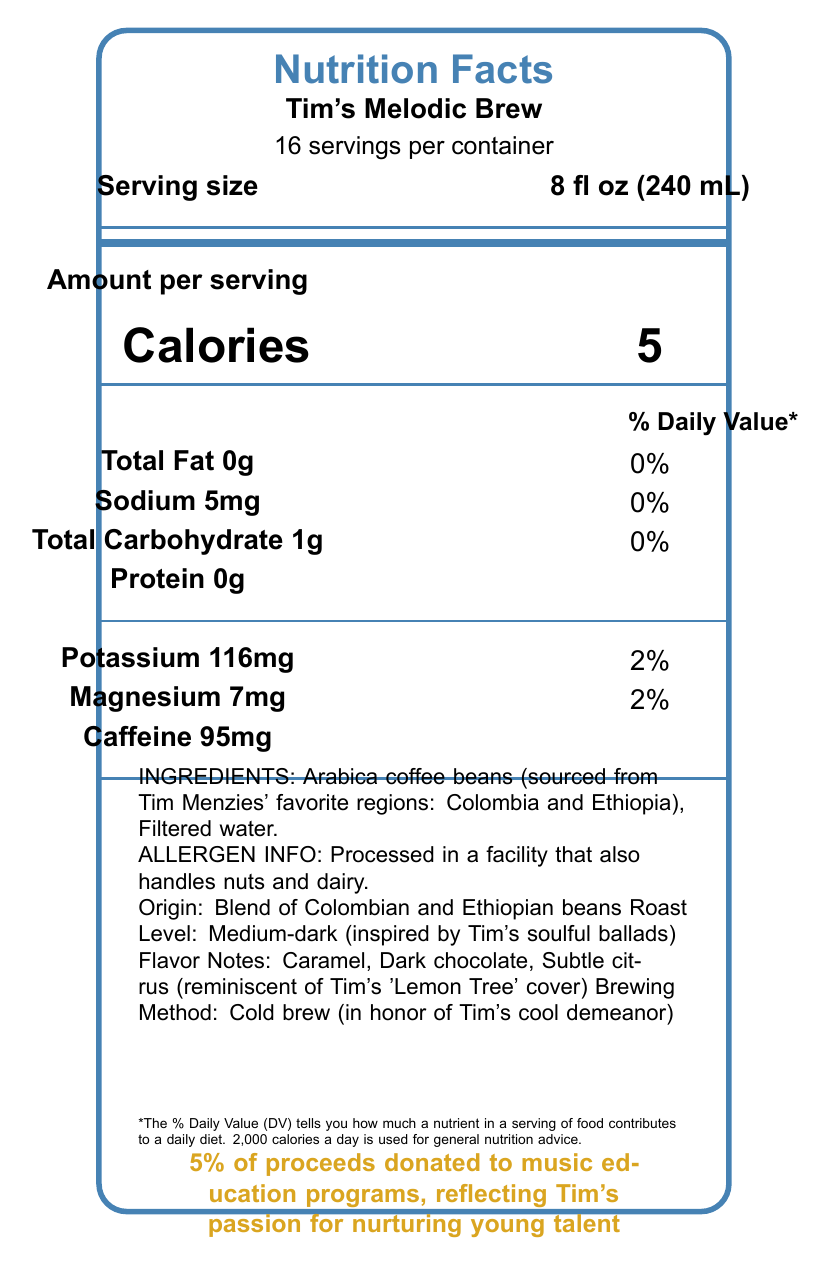What is the serving size of Tim's Melodic Brew? The serving size is clearly labeled as 8 fl oz (240 mL) in the document.
Answer: 8 fl oz (240 mL) How many servings are there per container of Tim's Melodic Brew? The label indicates that there are 16 servings per container.
Answer: 16 servings How many calories are there per serving of Tim's Melodic Brew? The document states that each serving contains 5 calories.
Answer: 5 calories What is the caffeine content per serving? The label lists that each serving contains 95mg of caffeine.
Answer: 95mg What allergen information is provided on the label? The allergen information is stated in the document and mentions processing in a facility that handles nuts and dairy.
Answer: Processed in a facility that also handles nuts and dairy How much potassium is in one serving of Tim's Melodic Brew? The label lists the potassium content as 116mg per serving.
Answer: 116mg What is the roast level of the coffee described in the document? The coffee is described as having a medium-dark roast inspired by Tim's soulful ballads.
Answer: Medium-dark Which of the following flavor notes are mentioned in the document? A. Vanilla B. Caramel C. Dark chocolate D. Nuts The document lists the flavor notes as caramel, dark chocolate, and subtle citrus.
Answer: B. Caramel, C. Dark chocolate Where are the coffee beans for Tim's Melodic Brew sourced from? A. Brazil B. Colombia and Ethiopia C. Kenya and Guatemala D. Vietnam The ingredients section specifies that the Arabica coffee beans are sourced from Colombia and Ethiopia, regions favored by Tim Menzies.
Answer: B. Colombia and Ethiopia Are there any vitamins or minerals listed on the Nutrition Facts label? The label lists potassium and magnesium with their respective amounts and daily values.
Answer: Yes What is the total carbohydrate content per serving? The document states that there is 1g of total carbohydrate per serving.
Answer: 1g Does Tim’s Melodic Brew contain any protein? The label indicates that there is 0g of protein per serving.
Answer: No Describe the main idea of the document. The document provides detailed information about the nutritional content, ingredients, origin, roast level, and additional notes on the specialty coffee, highlighting how it reflects Tim Menzies' musical influence and commitment to sustainability and charity.
Answer: The document is a Nutrition Facts label for Tim's Melodic Brew, a specialty coffee blend inspired by Tim Menzies' music. It details serving size, calories, caffeine content, vitamins and minerals, ingredients, allergen information, and unique features related to Tim's music and environmental commitments. What inspired the flavor notes of Tim's Melodic Brew? The flavor notes include subtle citrus which is reminiscent of Tim's 'Lemon Tree' cover, pointing to the source of inspiration.
Answer: Tim's 'Lemon Tree' cover What is the charitable contribution mentioned in the document? The document states that 5% of the proceeds from Tim's Melodic Brew are donated to music education programs, reflecting Tim's passion for nurturing young talent.
Answer: 5% of proceeds donated to music education programs Can you determine the costs of Tim's Melodic Brew from the document? The document does not provide any details about the pricing or costs of Tim's Melodic Brew.
Answer: Not enough information 